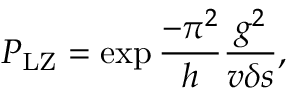Convert formula to latex. <formula><loc_0><loc_0><loc_500><loc_500>P _ { L Z } = \exp { { \frac { - \pi ^ { 2 } } { h } \frac { g ^ { 2 } } { v \delta s } } } ,</formula> 